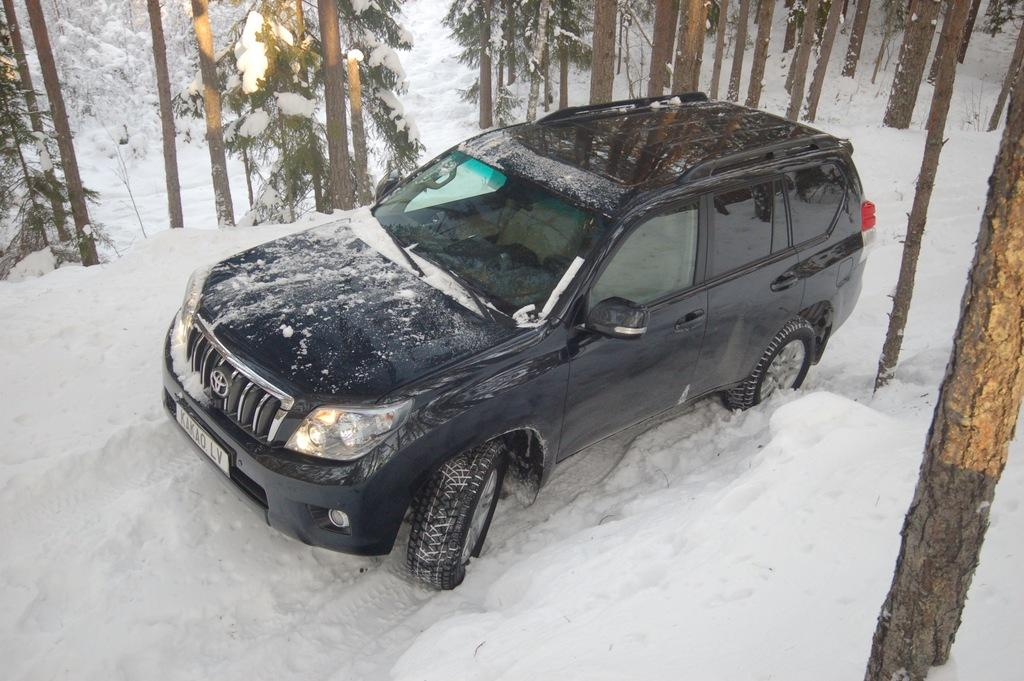What color is the car in the image? The car in the image is black. Where is the car located in the image? The car is in the snow. What is covering the car in the image? There is snow on the car. What can be seen in the background of the image? There are trees visible in the image. How many quarters are visible on the car in the image? There are no quarters visible on the car in the image. Can you tell me the credit score of the person who owns the car in the image? There is no information about the car owner's credit score in the image. 